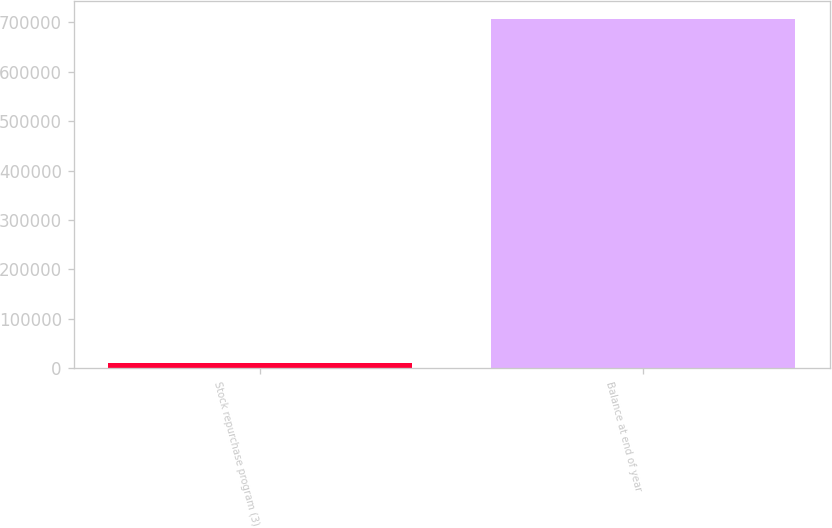Convert chart. <chart><loc_0><loc_0><loc_500><loc_500><bar_chart><fcel>Stock repurchase program (3)<fcel>Balance at end of year<nl><fcel>10126<fcel>706985<nl></chart> 